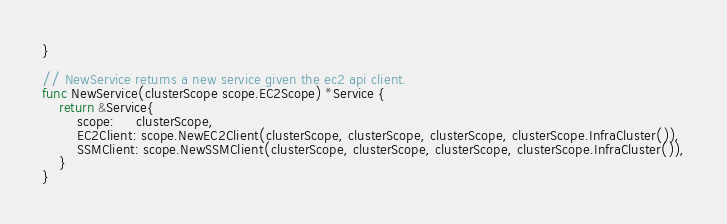Convert code to text. <code><loc_0><loc_0><loc_500><loc_500><_Go_>}

// NewService returns a new service given the ec2 api client.
func NewService(clusterScope scope.EC2Scope) *Service {
	return &Service{
		scope:     clusterScope,
		EC2Client: scope.NewEC2Client(clusterScope, clusterScope, clusterScope, clusterScope.InfraCluster()),
		SSMClient: scope.NewSSMClient(clusterScope, clusterScope, clusterScope, clusterScope.InfraCluster()),
	}
}
</code> 